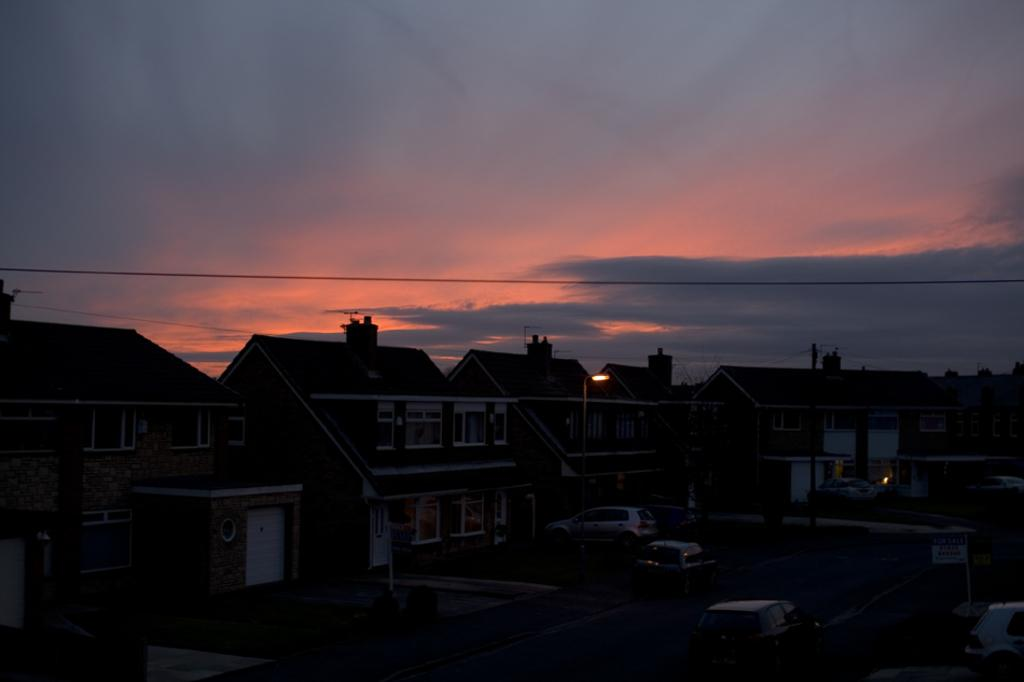What type of structures are present in the image? There are houses in the image. What features can be observed on the houses? The houses have roof tiles, windows, and chimneys on their roofs. What is visible in the background of the image? The sky is visible in the image. How would you describe the sky in the image? The sky appears to be a sunset sky. Can you tell me how the machine is helping the donkey in the image? There is no machine or donkey present in the image; it features houses with specific features and a sunset sky. 